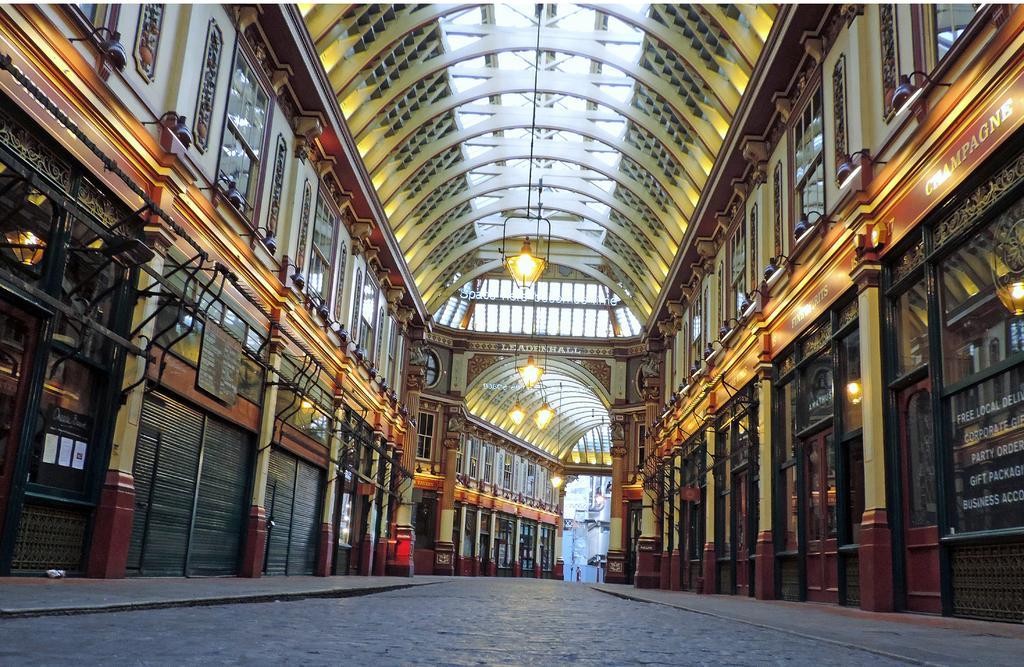In one or two sentences, can you explain what this image depicts? In this image there is a road at the bottom. There are pillars, windows, glass and metal objects and there is text on the left and right corner. There are lights on the roof at the top. We can see a person, roof, pillars in the background. 